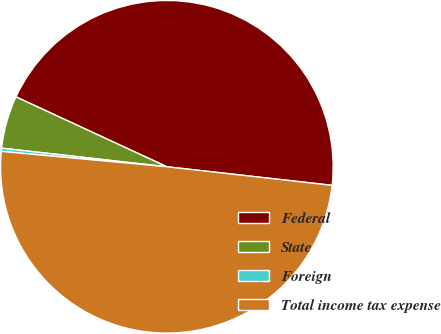Convert chart. <chart><loc_0><loc_0><loc_500><loc_500><pie_chart><fcel>Federal<fcel>State<fcel>Foreign<fcel>Total income tax expense<nl><fcel>44.88%<fcel>5.12%<fcel>0.31%<fcel>49.69%<nl></chart> 